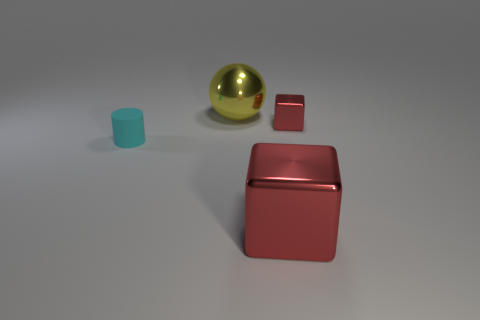Add 1 red metallic cubes. How many objects exist? 5 Subtract all cylinders. How many objects are left? 3 Add 2 yellow cubes. How many yellow cubes exist? 2 Subtract 0 brown cylinders. How many objects are left? 4 Subtract all small things. Subtract all small things. How many objects are left? 0 Add 4 cyan things. How many cyan things are left? 5 